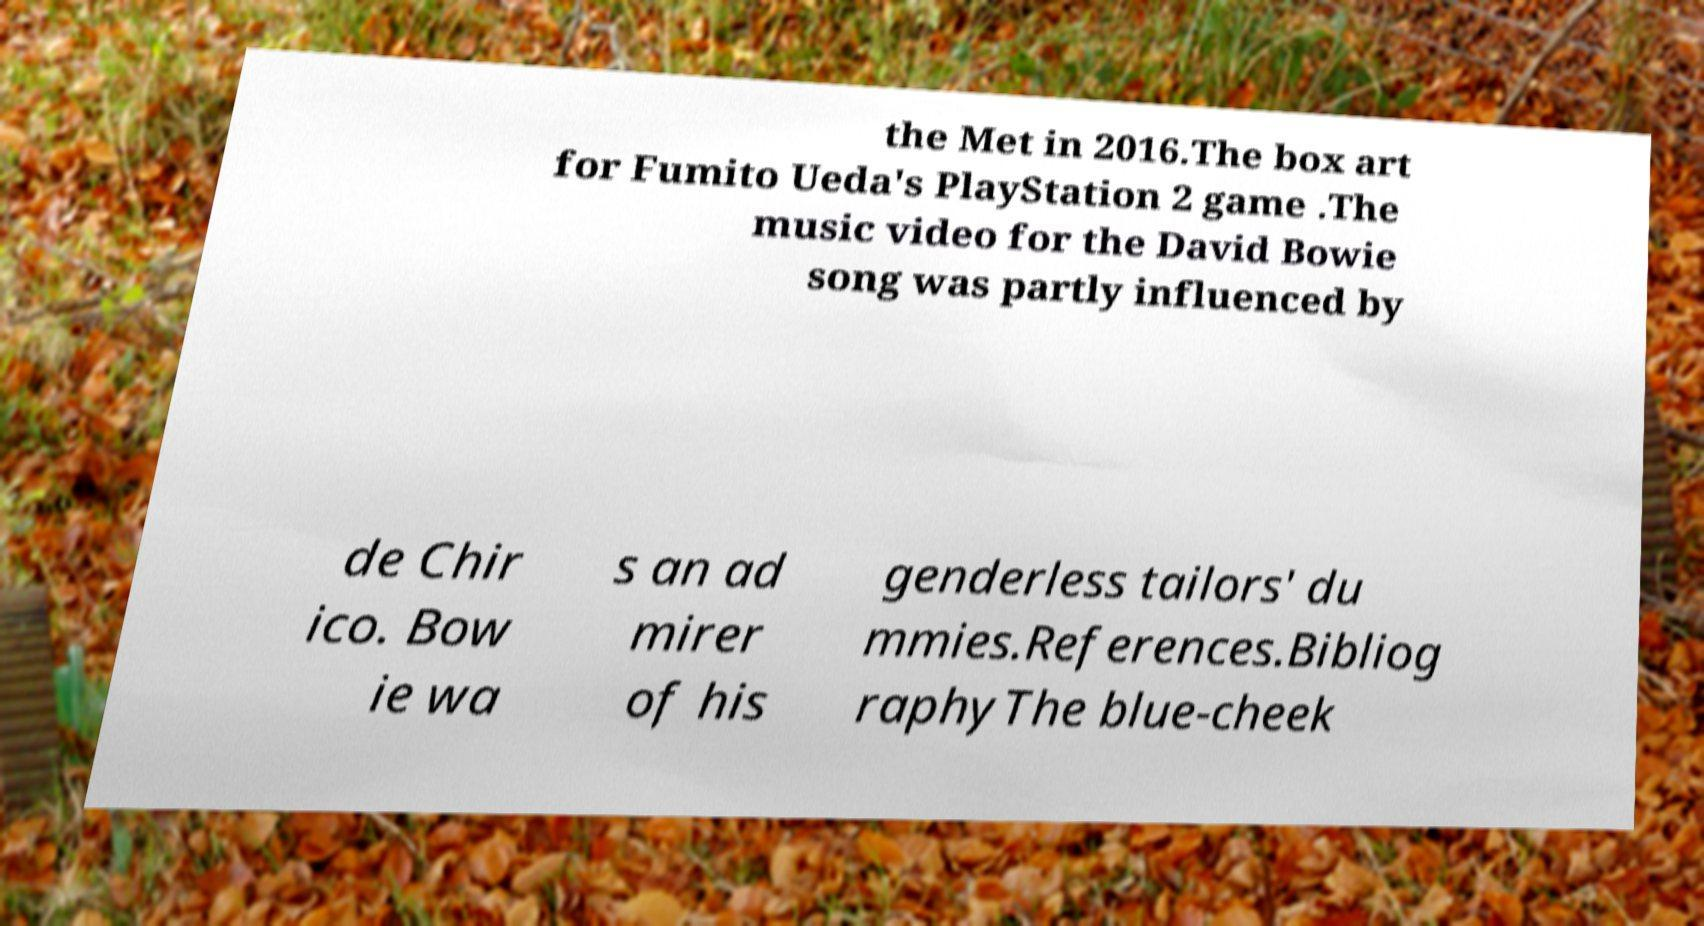There's text embedded in this image that I need extracted. Can you transcribe it verbatim? the Met in 2016.The box art for Fumito Ueda's PlayStation 2 game .The music video for the David Bowie song was partly influenced by de Chir ico. Bow ie wa s an ad mirer of his genderless tailors' du mmies.References.Bibliog raphyThe blue-cheek 